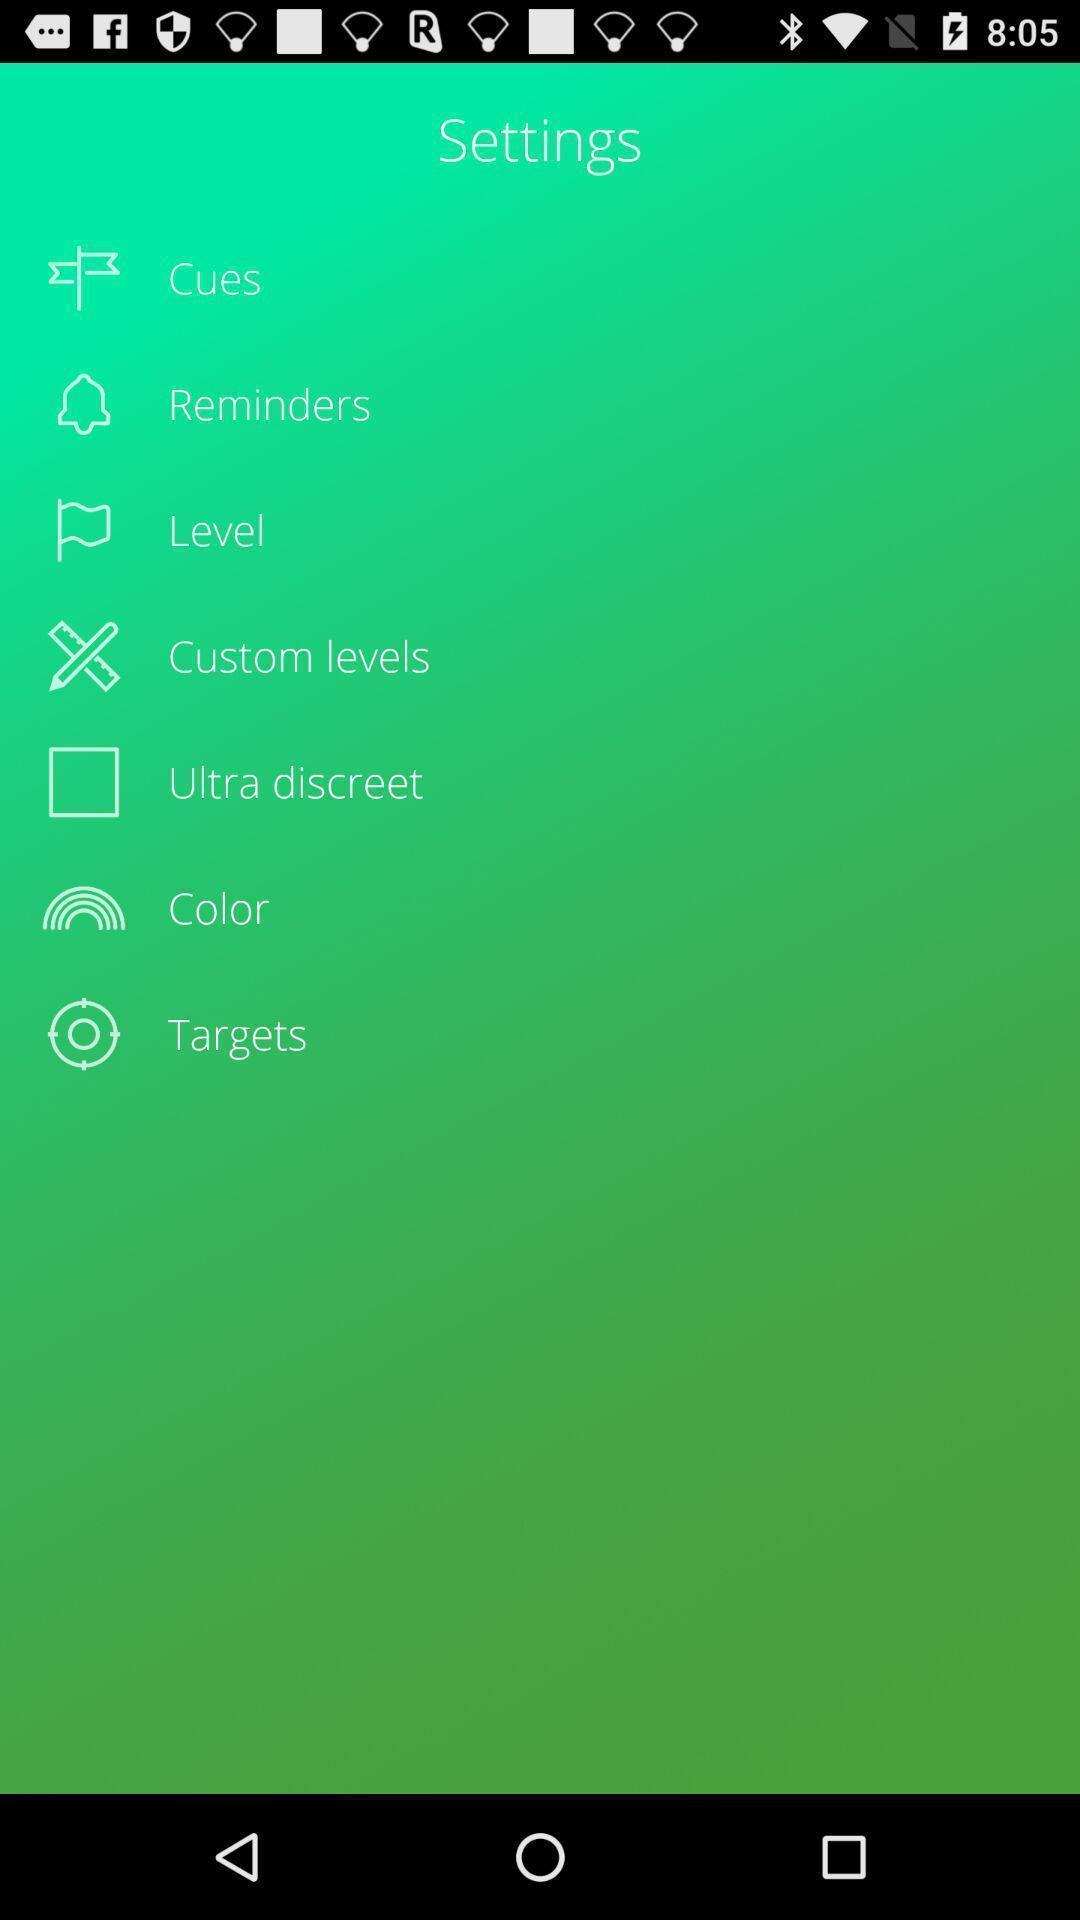Describe the key features of this screenshot. Settings page displayed of an fitness application. 